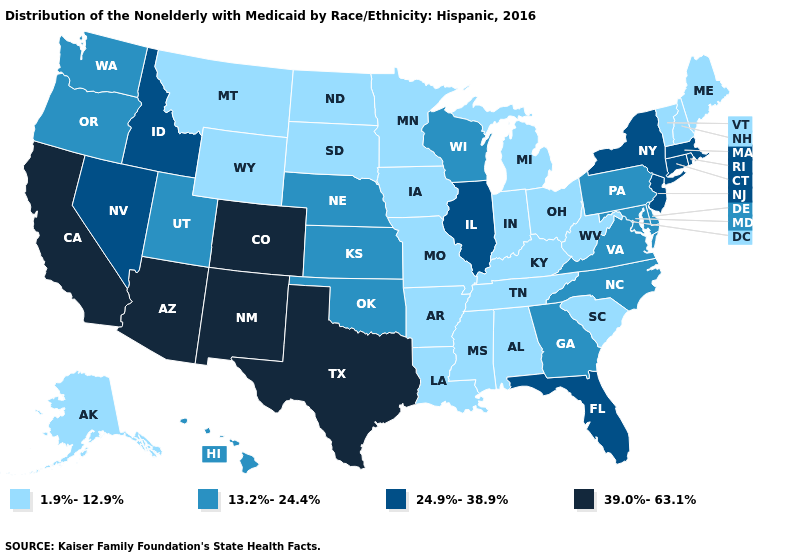Does Arkansas have the lowest value in the South?
Answer briefly. Yes. Name the states that have a value in the range 39.0%-63.1%?
Answer briefly. Arizona, California, Colorado, New Mexico, Texas. Does Alaska have the highest value in the West?
Be succinct. No. What is the value of Oklahoma?
Answer briefly. 13.2%-24.4%. What is the value of Washington?
Concise answer only. 13.2%-24.4%. Name the states that have a value in the range 13.2%-24.4%?
Write a very short answer. Delaware, Georgia, Hawaii, Kansas, Maryland, Nebraska, North Carolina, Oklahoma, Oregon, Pennsylvania, Utah, Virginia, Washington, Wisconsin. Name the states that have a value in the range 24.9%-38.9%?
Give a very brief answer. Connecticut, Florida, Idaho, Illinois, Massachusetts, Nevada, New Jersey, New York, Rhode Island. What is the value of North Dakota?
Short answer required. 1.9%-12.9%. Among the states that border Rhode Island , which have the lowest value?
Answer briefly. Connecticut, Massachusetts. Which states have the highest value in the USA?
Write a very short answer. Arizona, California, Colorado, New Mexico, Texas. What is the value of Idaho?
Be succinct. 24.9%-38.9%. Name the states that have a value in the range 13.2%-24.4%?
Keep it brief. Delaware, Georgia, Hawaii, Kansas, Maryland, Nebraska, North Carolina, Oklahoma, Oregon, Pennsylvania, Utah, Virginia, Washington, Wisconsin. Name the states that have a value in the range 13.2%-24.4%?
Give a very brief answer. Delaware, Georgia, Hawaii, Kansas, Maryland, Nebraska, North Carolina, Oklahoma, Oregon, Pennsylvania, Utah, Virginia, Washington, Wisconsin. Does the first symbol in the legend represent the smallest category?
Short answer required. Yes. What is the value of New Hampshire?
Concise answer only. 1.9%-12.9%. 